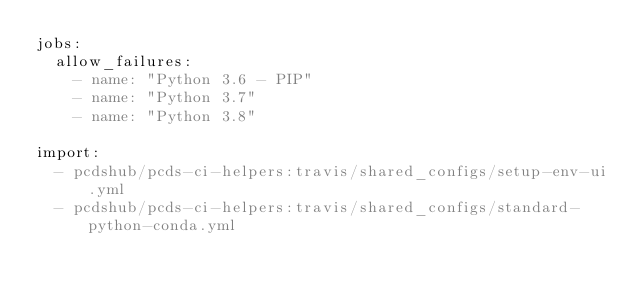Convert code to text. <code><loc_0><loc_0><loc_500><loc_500><_YAML_>jobs:
  allow_failures:
    - name: "Python 3.6 - PIP"
    - name: "Python 3.7"
    - name: "Python 3.8"

import:
  - pcdshub/pcds-ci-helpers:travis/shared_configs/setup-env-ui.yml
  - pcdshub/pcds-ci-helpers:travis/shared_configs/standard-python-conda.yml
</code> 